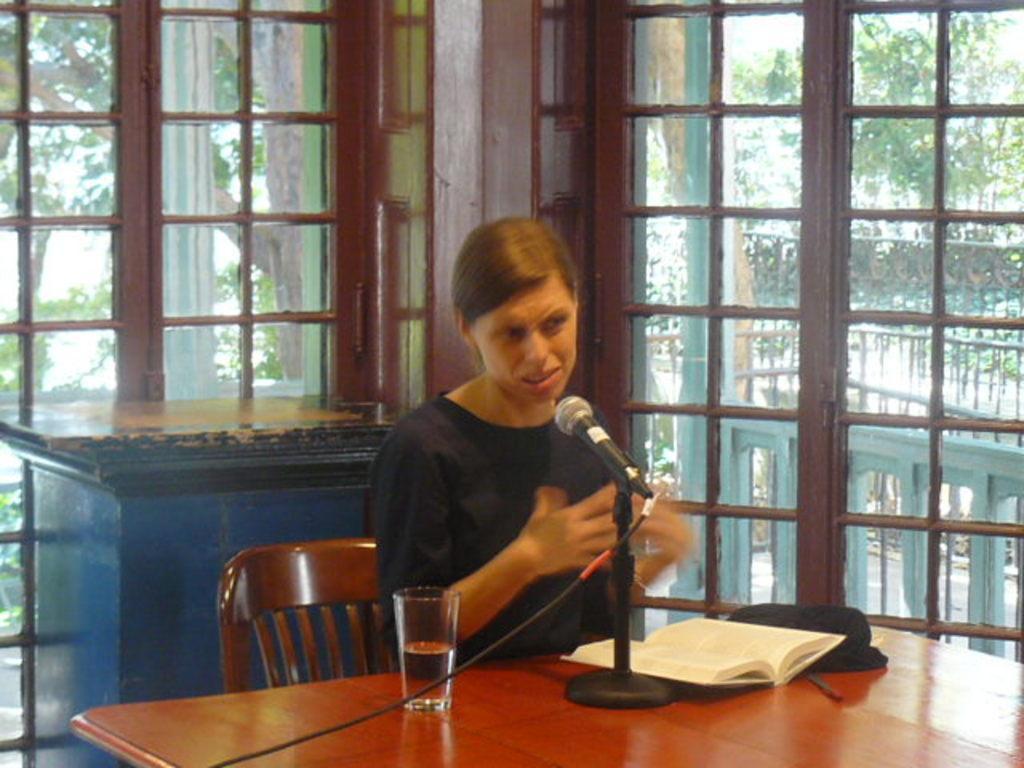In one or two sentences, can you explain what this image depicts? In this picture we can see a woman sitting on a chair and in front of her on the table we can see a mic, book, glass and in the background we can see windows, trees. 